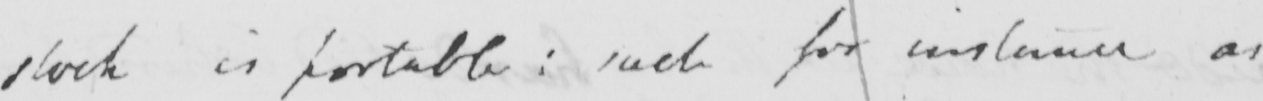Please provide the text content of this handwritten line. stock is portable :  such for instance as 